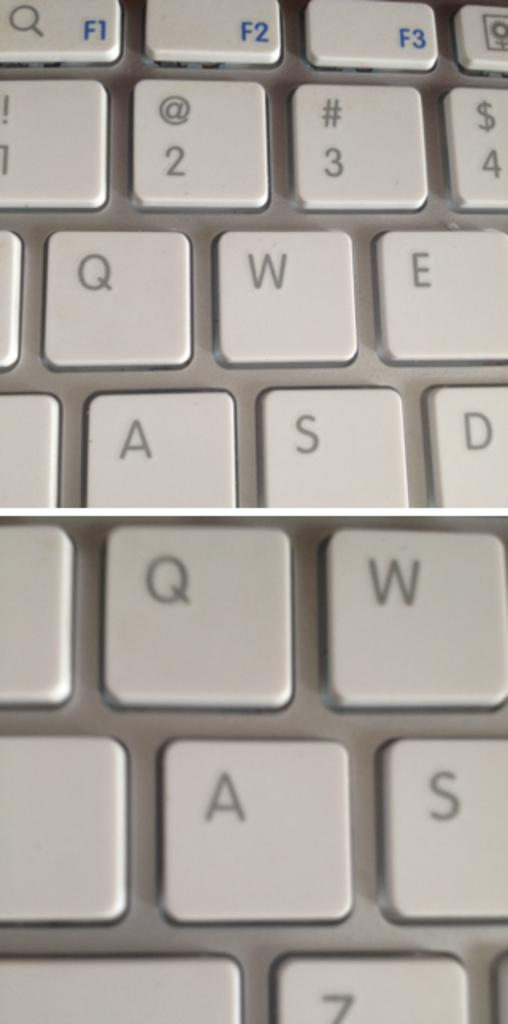<image>
Describe the image concisely. The top middle blue button is the key for F3 